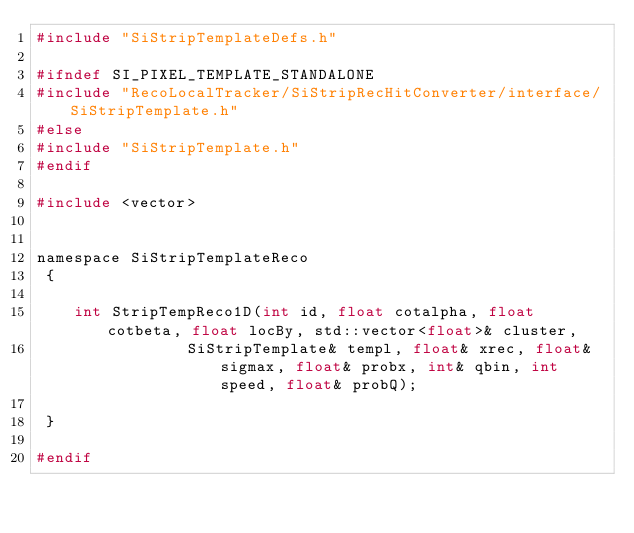<code> <loc_0><loc_0><loc_500><loc_500><_C_>#include "SiStripTemplateDefs.h"

#ifndef SI_PIXEL_TEMPLATE_STANDALONE
#include "RecoLocalTracker/SiStripRecHitConverter/interface/SiStripTemplate.h"
#else
#include "SiStripTemplate.h"
#endif

#include <vector>


namespace SiStripTemplateReco 
 {

	int StripTempReco1D(int id, float cotalpha, float cotbeta, float locBy, std::vector<float>& cluster, 
				SiStripTemplate& templ, float& xrec, float& sigmax, float& probx, int& qbin, int speed, float& probQ);

 }
				
#endif
</code> 